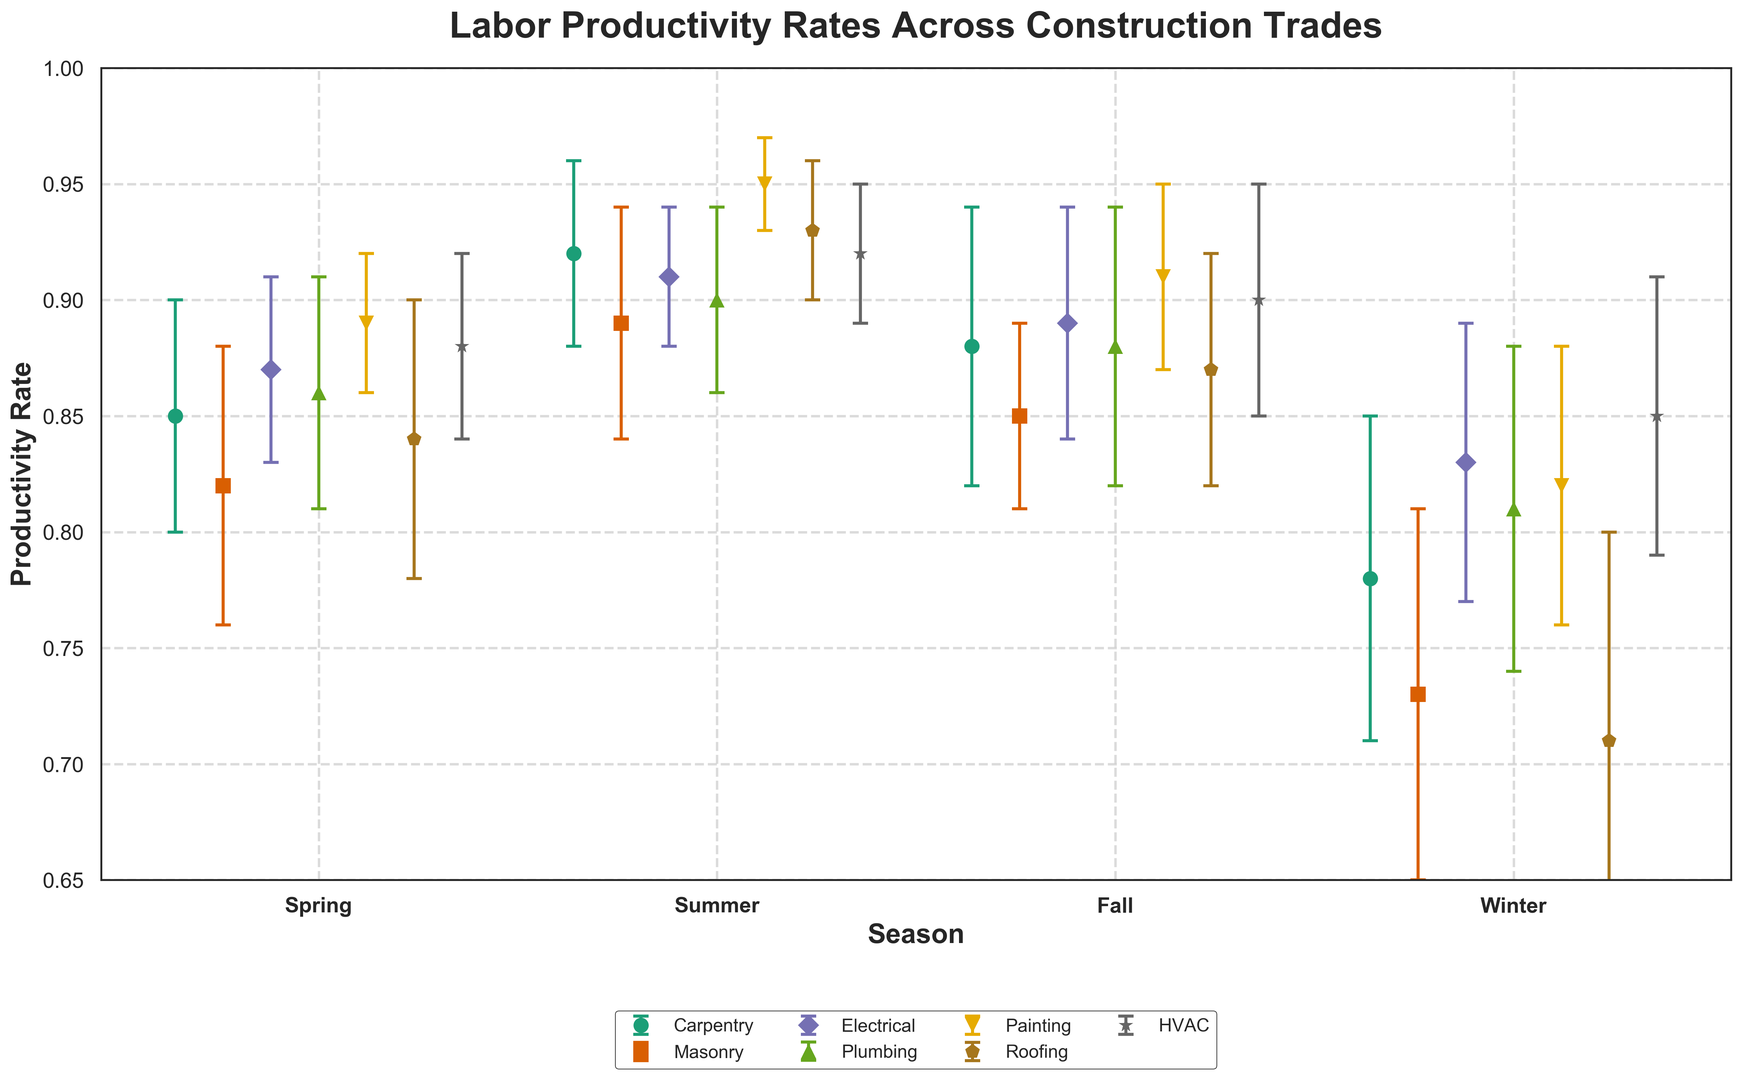Which trade has the highest productivity rate in the summer? Look for the summer category on the x-axis, then compare the heights of error bars for all trades. The highest point corresponds to the highest productivity rate.
Answer: Painting Which season has the lowest productivity rate for Roofing? Identify the Roofing trade by its marker and color, then compare the heights of error bars across all seasons. The lowest point indicates the lowest productivity rate.
Answer: Winter What is the average productivity rate across all trades in the Spring? Find the Spring category on the x-axis and note the productivity rates for all trades. Add these values and divide by the number of trades: (0.85 + 0.82 + 0.87 + 0.86 + 0.89 + 0.84 + 0.88) / 7 = 6.01 / 7 ≈ 0.86
Answer: 0.86 Between Carpentry and Masonry, which has a higher productivity rate in Fall and by how much? Find the Fall category on the x-axis, then compare the productivity rates for Carpentry and Masonry. Carpentry is 0.88 and Masonry is 0.85. The difference is 0.88 - 0.85 = 0.03
Answer: Carpentry by 0.03 What is the range of productivity rates for Plumbing throughout the year? Identify the Plumbing trade and note the productivity rates for all seasons: Spring (0.86), Summer (0.90), Fall (0.88), Winter (0.81). The range is the difference between the highest and lowest values: 0.90 - 0.81 = 0.09
Answer: 0.09 Which season shows the most significant variation in productivity rates across all trades? Look for the season with the widest spread of error bars. Identify the longest range between the highest and lowest productivity rates.
Answer: Winter Compare the productivity rates of Electrical in Summer and Winter. How much does it decrease? Note the productivity rates of Electrical for Summer (0.91) and Winter (0.83). The decrease is 0.91 - 0.83 = 0.08
Answer: 0.08 Which trade has the smallest error margin in Fall? In the Fall category, compare the error bars (vertical lines) for all trades. The smallest error margin corresponds to the shortest error bar.
Answer: Masonry What is the difference in productivity rates between HVAC and Painting in the Summer? Identify the productivity rates of HVAC (0.92) and Painting (0.95) in the Summer. The difference is 0.95 - 0.92 = 0.03
Answer: 0.03 Which trade has the consistently high productivity rate throughout the seasons? Identify the trade with error bars that consistently remain at the upper end of the y-axis across all seasons.
Answer: Painting 